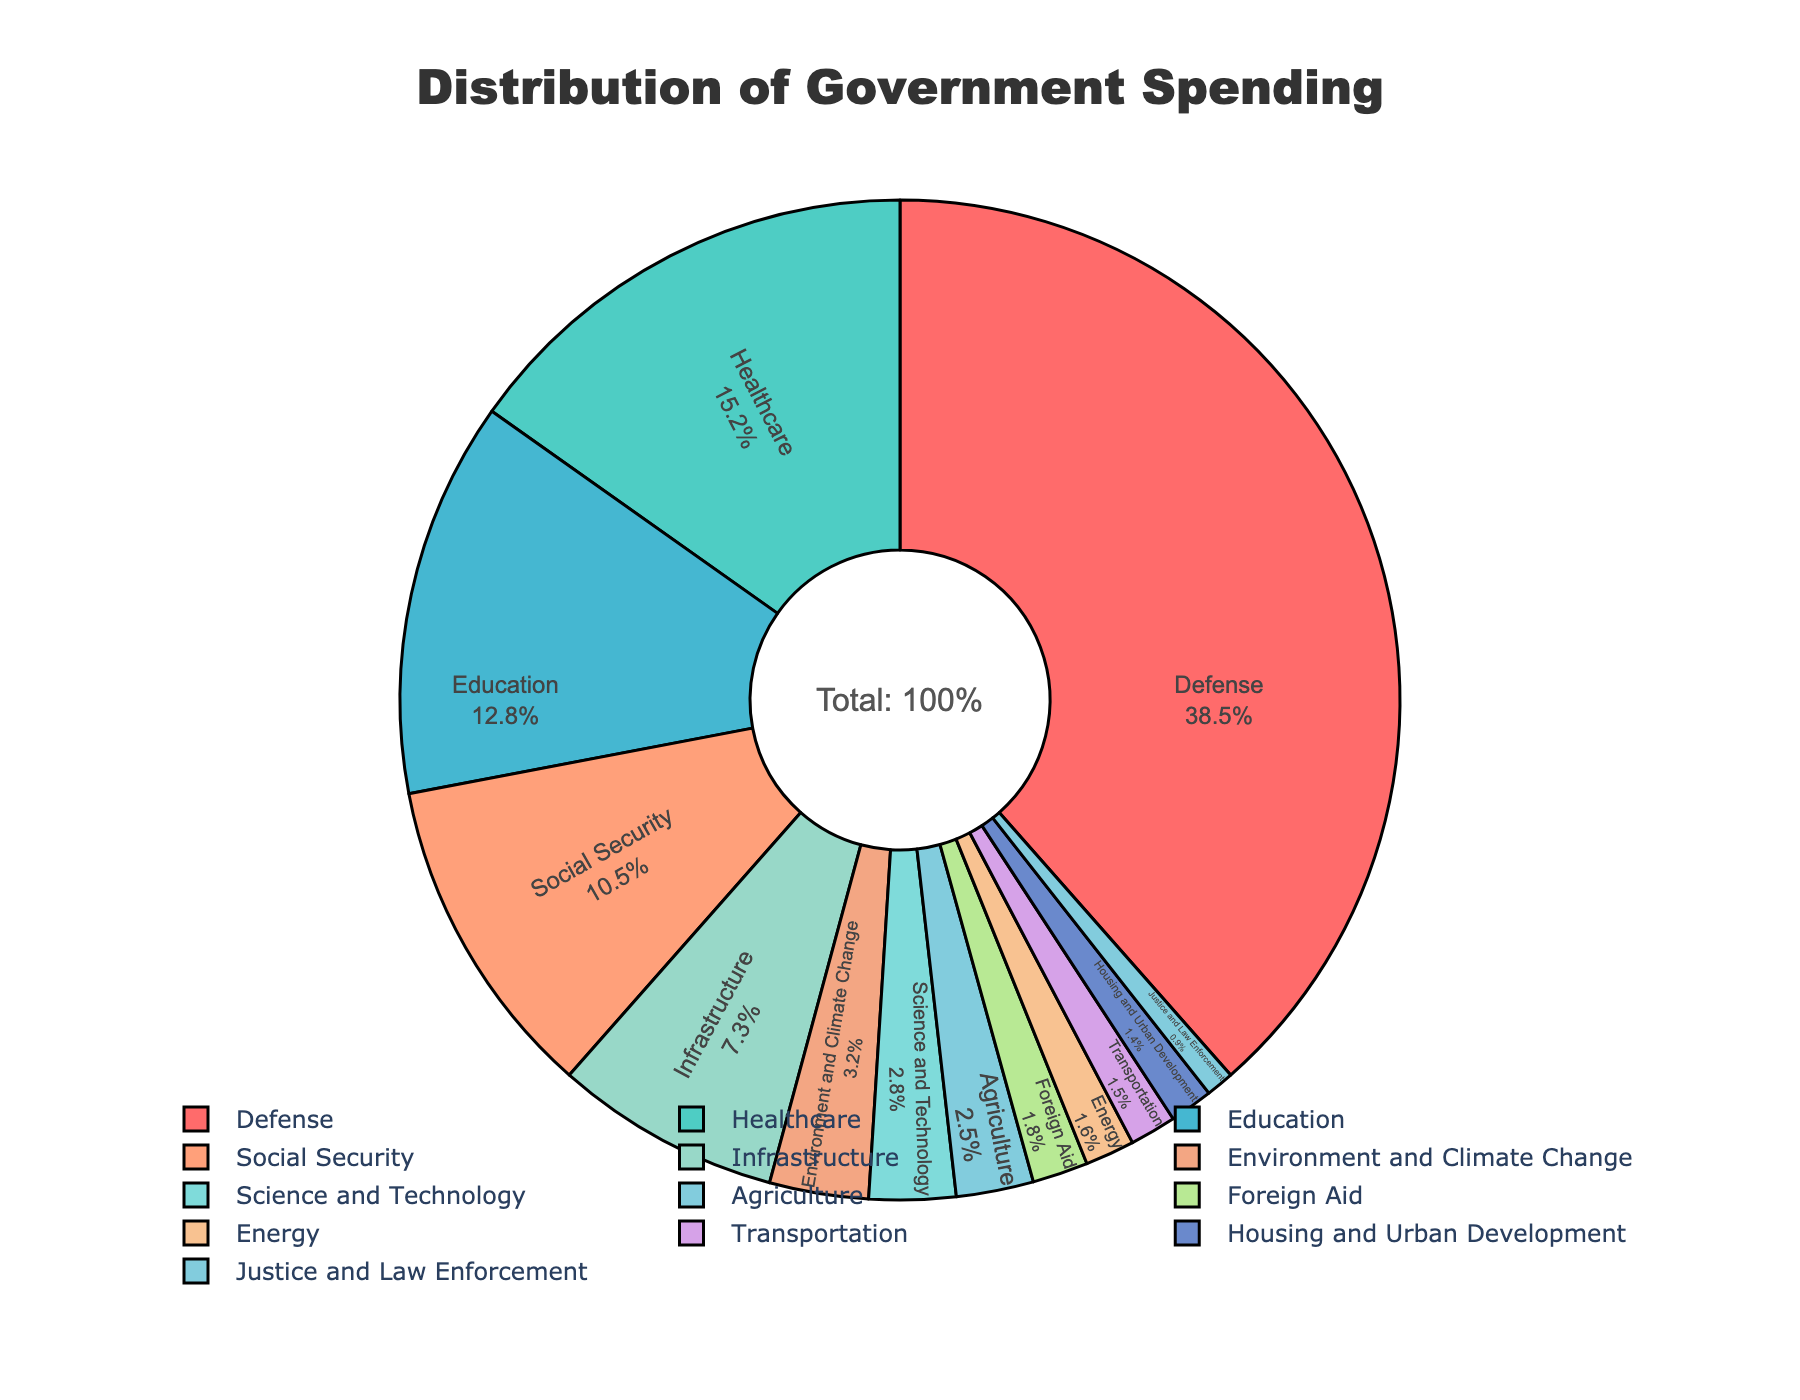What percentage of government spending goes to environmental and climate change initiatives? The pie chart shows that the Environment and Climate Change sector accounts for 3.2% of the total government spending.
Answer: 3.2% How much more is spent on defense compared to education? The pie chart reveals that defense spending is 38.5% and education spending is 12.8%. The difference is 38.5% - 12.8% = 25.7%.
Answer: 25.7% Which sector receives the second-highest portion of government spending? From the pie chart, healthcare spending is 15.2%, which is the second-highest after defense (38.5%).
Answer: Healthcare What is the combined percentage of spending on social security and infrastructure? The chart shows that social security receives 10.5% and infrastructure receives 7.3%. Adding these together: 10.5% + 7.3% = 17.8%.
Answer: 17.8% How does the spending on agriculture compare to that on science and technology? The pie chart shows that science and technology receive 2.8% of the spending, whereas agriculture gets 2.5%. Therefore, science and technology receive 0.3% more.
Answer: 0.3% Identify the sectors with a spending percentage less than 2%. By examining the pie chart, we see that Foreign Aid (1.8%), Energy (1.6%), Transportation (1.5%), Housing and Urban Development (1.4%), and Justice and Law Enforcement (0.9%) all have spending below 2%.
Answer: Foreign Aid, Energy, Transportation, Housing and Urban Development, Justice and Law Enforcement What is the range of percentages in the distribution of government spending? The minimum percentage is for Justice and Law Enforcement at 0.9%, and the maximum is for Defense at 38.5%. Thus, the range is 38.5% - 0.9% = 37.6%.
Answer: 37.6% What percentage of government spending is allocated to sectors other than defense and environment? Summing the percentages of all other sectors apart from defense (38.5%) and environment (3.2%): 100% - (38.5% + 3.2%) = 100% - 41.7% = 58.3%.
Answer: 58.3% Between healthcare and education, which sector receives more funding, and by how much? The pie chart indicates healthcare receives 15.2% and education receives 12.8%. The difference is 15.2% - 12.8% = 2.4%.
Answer: Healthcare by 2.4% What sectors have spending percentages that are visually represented in the same or similar color? By examining the chart, sectors like Infrastructure (7.3%) and Science and Technology (2.8%) appear to be represented in shades of blue, while others such as Healthcare (15.2%) and Environment and Climate Change (3.2%) have green shades.
Answer: Infrastructure and Science and Technology; Healthcare and Environment and Climate Change 